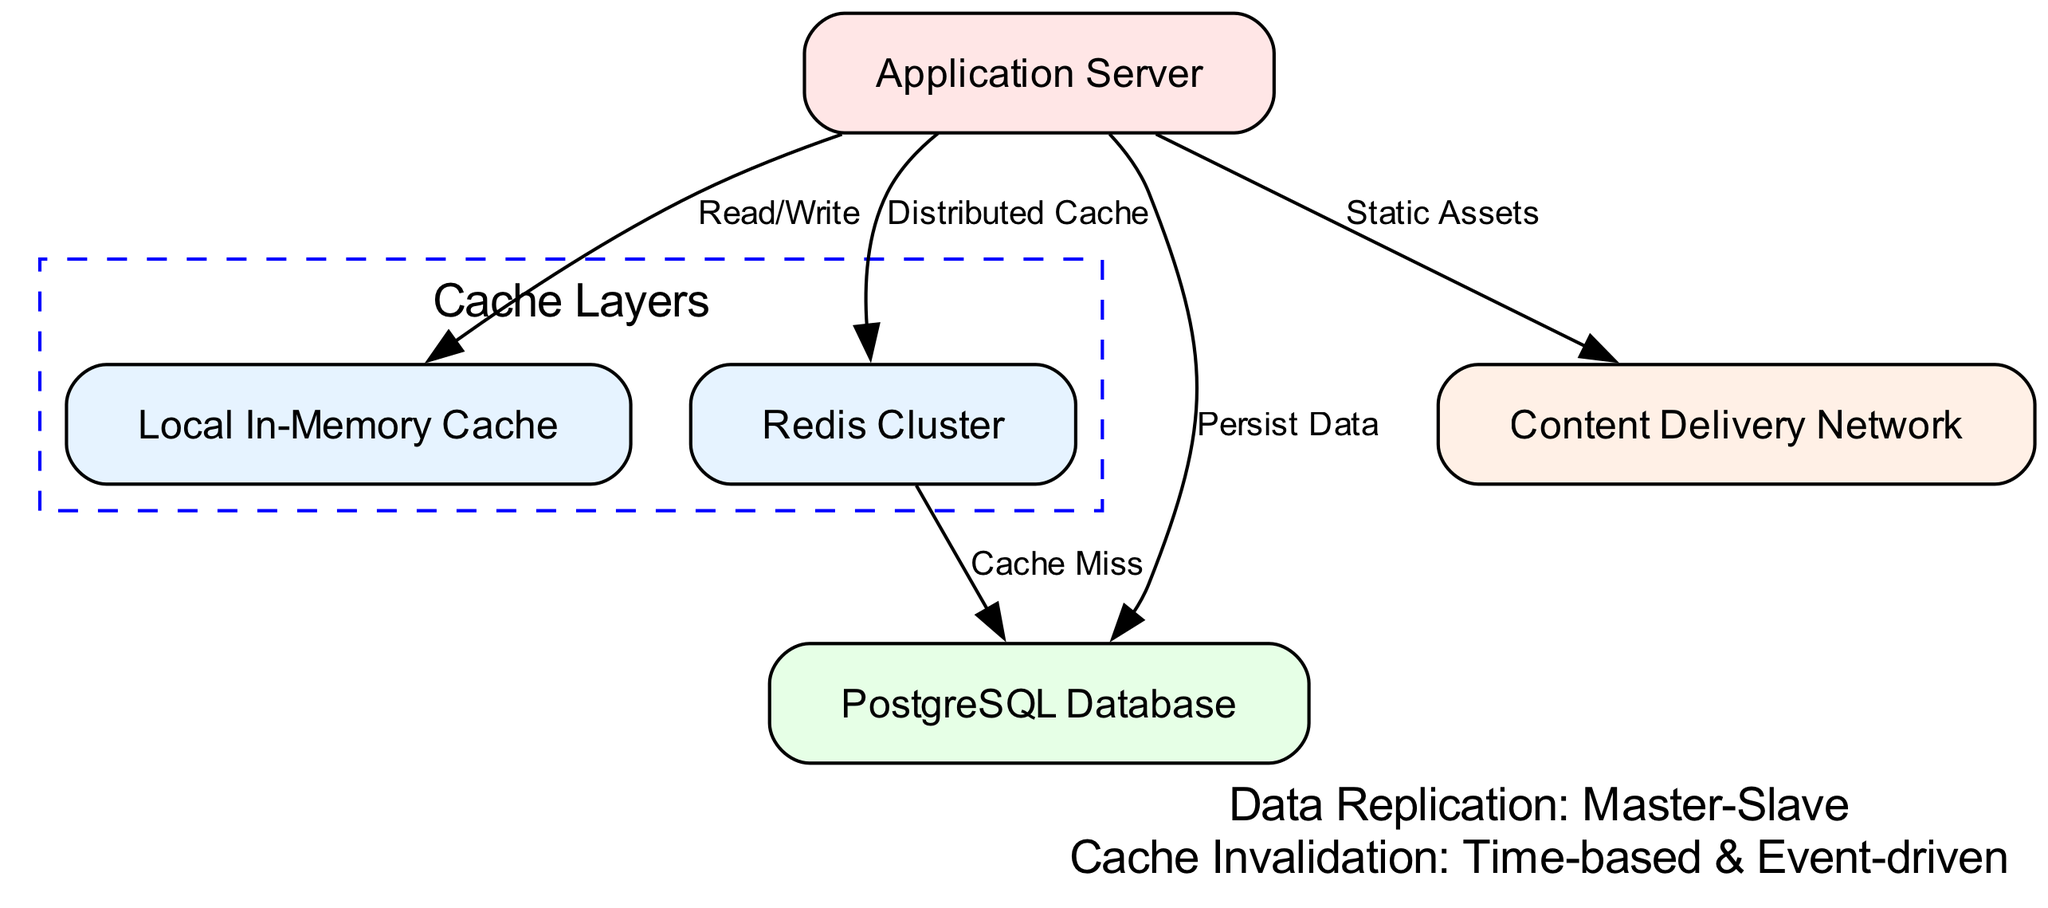What is the total number of nodes in the diagram? The diagram displays a total of five nodes: Application Server, Local In-Memory Cache, Redis Cluster, PostgreSQL Database, and Content Delivery Network. By counting each of these, we arrive at the total number of nodes.
Answer: 5 What type of cache is represented by "Local In-Memory Cache"? The "Local In-Memory Cache" node is depicted as a caching layer close to the Application Server. It is specifically and distinctly labeled as a "Local" cache, indicating its function as an immediate storage mechanism for the application.
Answer: Local Which nodes are included in the "Cache Layers" group? The "Cache Layers" group contains the nodes labeled "Local In-Memory Cache" and "Redis Cluster." By identifying the nodes mentioned in the cache layers' subgraph, we find these two.
Answer: Local In-Memory Cache, Redis Cluster What action does the Application Server perform towards the PostgreSQL Database? According to the diagram, the Application Server conducts a "Persist Data" action directed at the PostgreSQL Database. This relationship indicates that the application saves or writes data to the database.
Answer: Persist Data How does the Redis Cluster interact with the PostgreSQL Database? The connection from the Redis Cluster to the PostgreSQL Database is labeled as "Cache Miss." This implies that when data is not found in the Redis Cache, it queries the PostgreSQL Database, which serves as the main storage, retrieving the required data.
Answer: Cache Miss What type of data replication strategy is indicated in the diagram? The annotation at the bottom of the diagram specifies "Master-Slave" as the data replication strategy. This strategy involves a primary node (master) that handles writes, while one or more secondary nodes (slaves) replicate the data for redundancy and read purposes.
Answer: Master-Slave What does the Application Server do with static assets? The Application Server sends or retrieves "Static Assets" to/from the Content Delivery Network, indicating that it utilizes the CDN for faster delivery of static content, which can improve performance.
Answer: Static Assets What two methods of cache invalidation are indicated in the diagram? The annotation to the right of the diagram includes "Time-based & Event-driven" to describe the methods of cache invalidation. This means that the cache can be invalidated based on either a set time period or events that trigger updates.
Answer: Time-based & Event-driven 